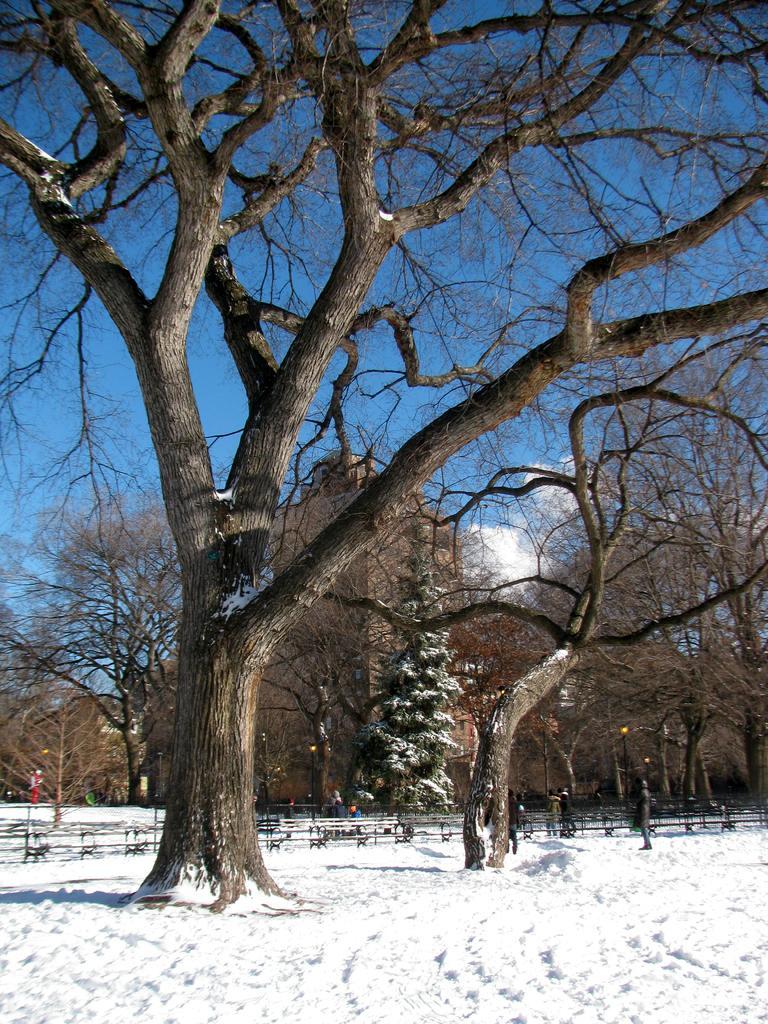Describe this image in one or two sentences. In this picture we can see some trees, snow, some trees are covered with snow. 